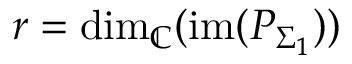<formula> <loc_0><loc_0><loc_500><loc_500>r = d i m _ { \mathbb { C } } ( i m ( P _ { \Sigma _ { 1 } } ) )</formula> 